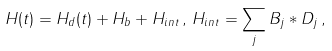<formula> <loc_0><loc_0><loc_500><loc_500>H ( t ) = H _ { d } ( t ) + H _ { b } + H _ { i n t } \, , \, H _ { i n t } = \sum _ { j } B _ { j } * D _ { j } \, ,</formula> 